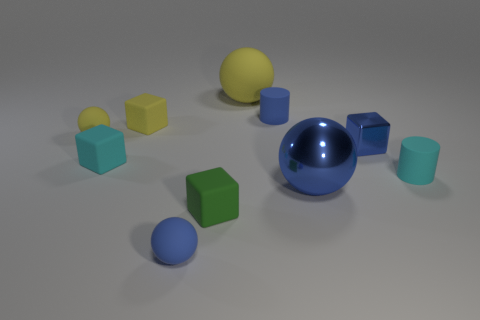Subtract all yellow blocks. Subtract all gray cylinders. How many blocks are left? 3 Subtract all spheres. How many objects are left? 6 Add 9 tiny cyan matte cylinders. How many tiny cyan matte cylinders are left? 10 Add 10 large cyan rubber objects. How many large cyan rubber objects exist? 10 Subtract 0 purple balls. How many objects are left? 10 Subtract all cylinders. Subtract all small things. How many objects are left? 0 